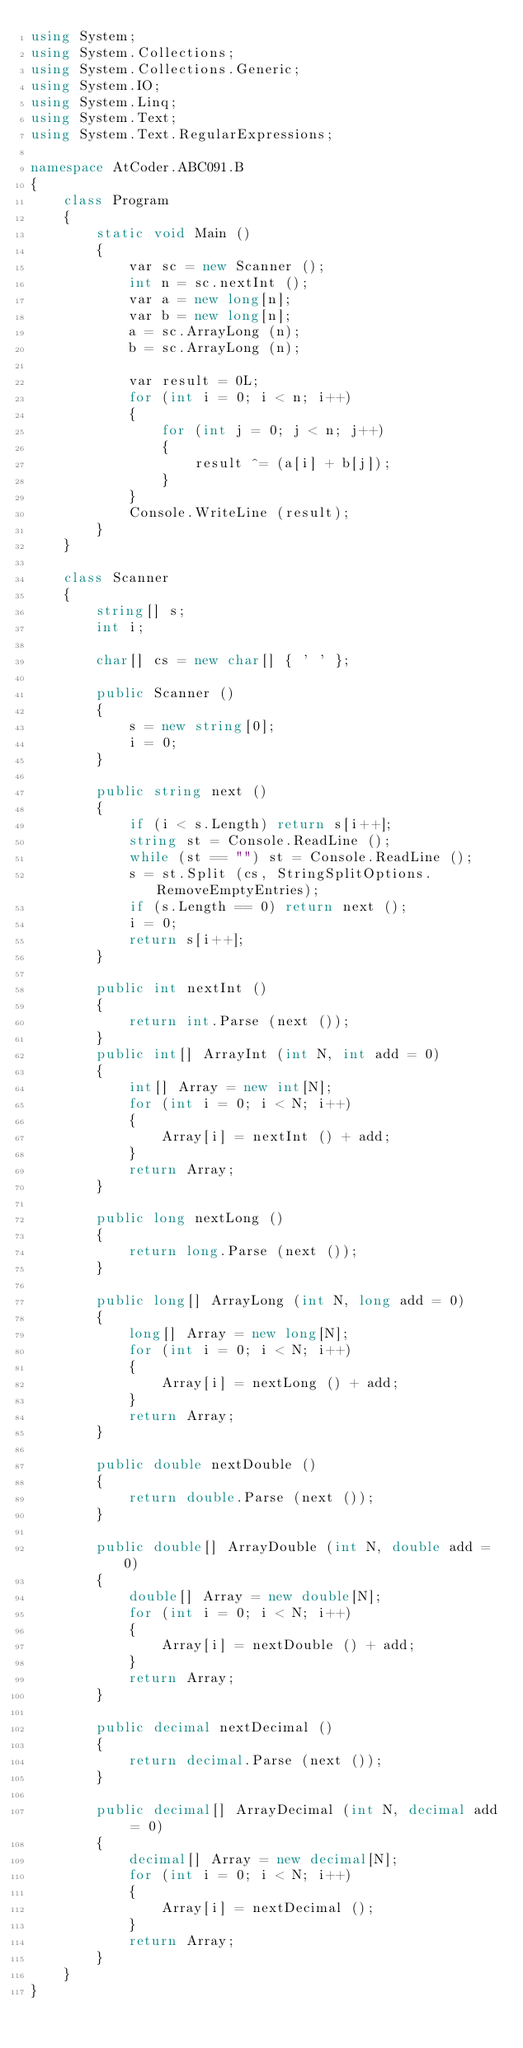<code> <loc_0><loc_0><loc_500><loc_500><_C#_>using System;
using System.Collections;
using System.Collections.Generic;
using System.IO;
using System.Linq;
using System.Text;
using System.Text.RegularExpressions;

namespace AtCoder.ABC091.B
{
    class Program
    {
        static void Main ()
        {
            var sc = new Scanner ();
            int n = sc.nextInt ();
            var a = new long[n];
            var b = new long[n];
            a = sc.ArrayLong (n);
            b = sc.ArrayLong (n);

            var result = 0L;
            for (int i = 0; i < n; i++)
            {
                for (int j = 0; j < n; j++)
                {
                    result ^= (a[i] + b[j]);
                }
            }
            Console.WriteLine (result);
        }
    }

    class Scanner
    {
        string[] s;
        int i;

        char[] cs = new char[] { ' ' };

        public Scanner ()
        {
            s = new string[0];
            i = 0;
        }

        public string next ()
        {
            if (i < s.Length) return s[i++];
            string st = Console.ReadLine ();
            while (st == "") st = Console.ReadLine ();
            s = st.Split (cs, StringSplitOptions.RemoveEmptyEntries);
            if (s.Length == 0) return next ();
            i = 0;
            return s[i++];
        }

        public int nextInt ()
        {
            return int.Parse (next ());
        }
        public int[] ArrayInt (int N, int add = 0)
        {
            int[] Array = new int[N];
            for (int i = 0; i < N; i++)
            {
                Array[i] = nextInt () + add;
            }
            return Array;
        }

        public long nextLong ()
        {
            return long.Parse (next ());
        }

        public long[] ArrayLong (int N, long add = 0)
        {
            long[] Array = new long[N];
            for (int i = 0; i < N; i++)
            {
                Array[i] = nextLong () + add;
            }
            return Array;
        }

        public double nextDouble ()
        {
            return double.Parse (next ());
        }

        public double[] ArrayDouble (int N, double add = 0)
        {
            double[] Array = new double[N];
            for (int i = 0; i < N; i++)
            {
                Array[i] = nextDouble () + add;
            }
            return Array;
        }

        public decimal nextDecimal ()
        {
            return decimal.Parse (next ());
        }

        public decimal[] ArrayDecimal (int N, decimal add = 0)
        {
            decimal[] Array = new decimal[N];
            for (int i = 0; i < N; i++)
            {
                Array[i] = nextDecimal ();
            }
            return Array;
        }
    }
}</code> 